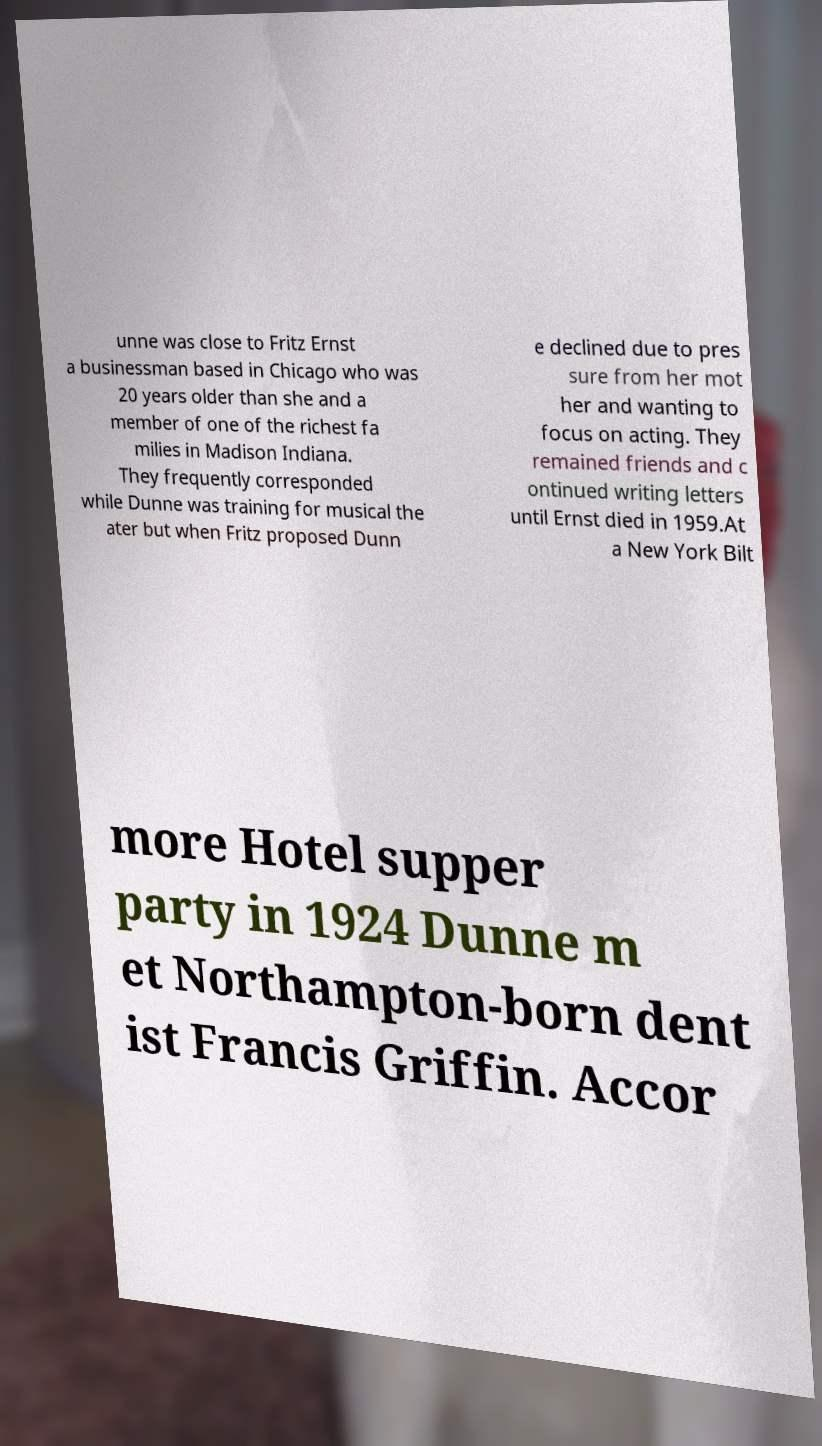There's text embedded in this image that I need extracted. Can you transcribe it verbatim? unne was close to Fritz Ernst a businessman based in Chicago who was 20 years older than she and a member of one of the richest fa milies in Madison Indiana. They frequently corresponded while Dunne was training for musical the ater but when Fritz proposed Dunn e declined due to pres sure from her mot her and wanting to focus on acting. They remained friends and c ontinued writing letters until Ernst died in 1959.At a New York Bilt more Hotel supper party in 1924 Dunne m et Northampton-born dent ist Francis Griffin. Accor 